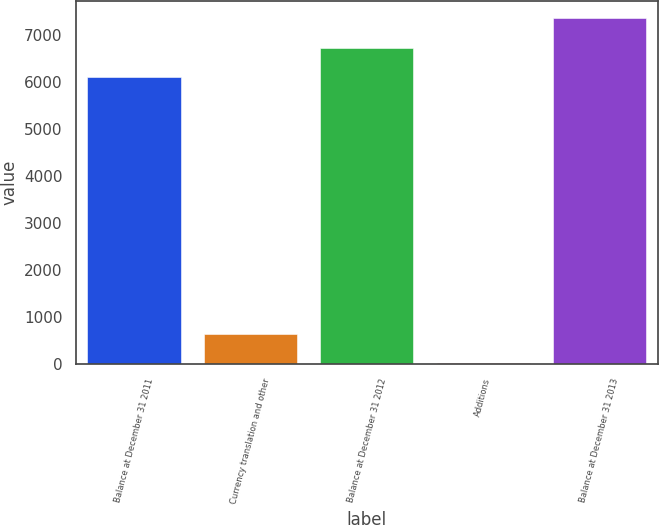<chart> <loc_0><loc_0><loc_500><loc_500><bar_chart><fcel>Balance at December 31 2011<fcel>Currency translation and other<fcel>Balance at December 31 2012<fcel>Additions<fcel>Balance at December 31 2013<nl><fcel>6100<fcel>650.2<fcel>6725.2<fcel>25<fcel>7350.4<nl></chart> 